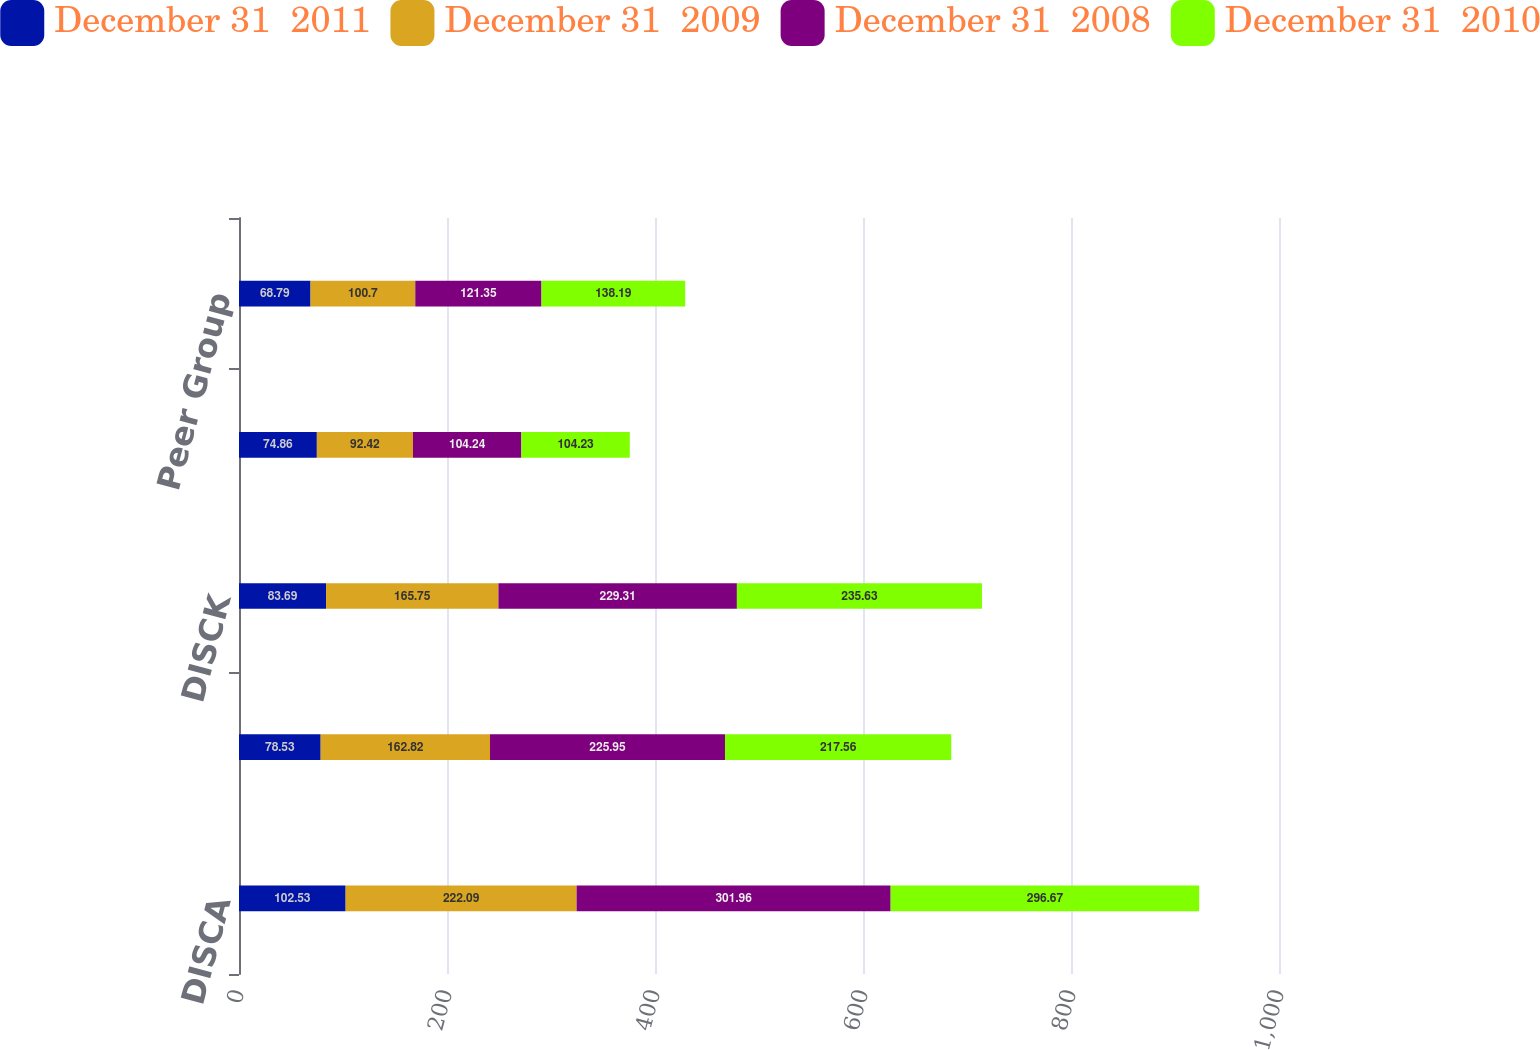Convert chart. <chart><loc_0><loc_0><loc_500><loc_500><stacked_bar_chart><ecel><fcel>DISCA<fcel>DISCB<fcel>DISCK<fcel>S&P 500<fcel>Peer Group<nl><fcel>December 31  2011<fcel>102.53<fcel>78.53<fcel>83.69<fcel>74.86<fcel>68.79<nl><fcel>December 31  2009<fcel>222.09<fcel>162.82<fcel>165.75<fcel>92.42<fcel>100.7<nl><fcel>December 31  2008<fcel>301.96<fcel>225.95<fcel>229.31<fcel>104.24<fcel>121.35<nl><fcel>December 31  2010<fcel>296.67<fcel>217.56<fcel>235.63<fcel>104.23<fcel>138.19<nl></chart> 